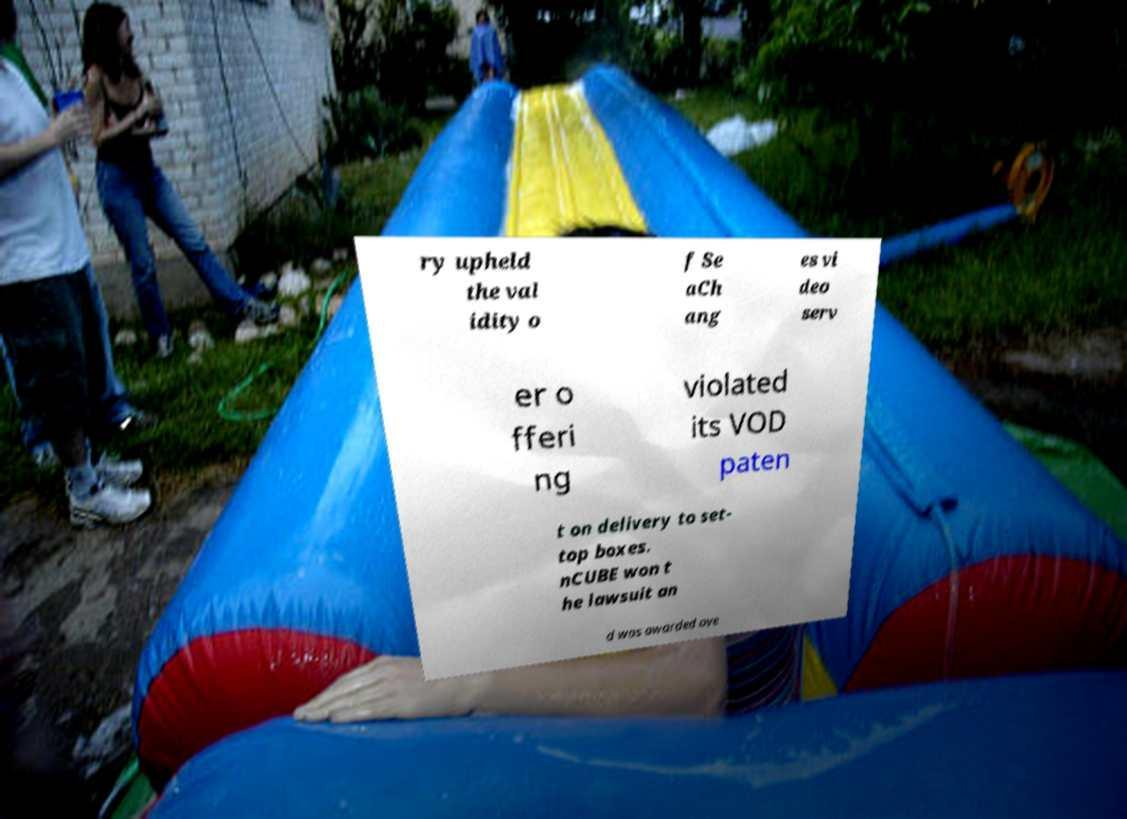Could you assist in decoding the text presented in this image and type it out clearly? ry upheld the val idity o f Se aCh ang es vi deo serv er o fferi ng violated its VOD paten t on delivery to set- top boxes. nCUBE won t he lawsuit an d was awarded ove 